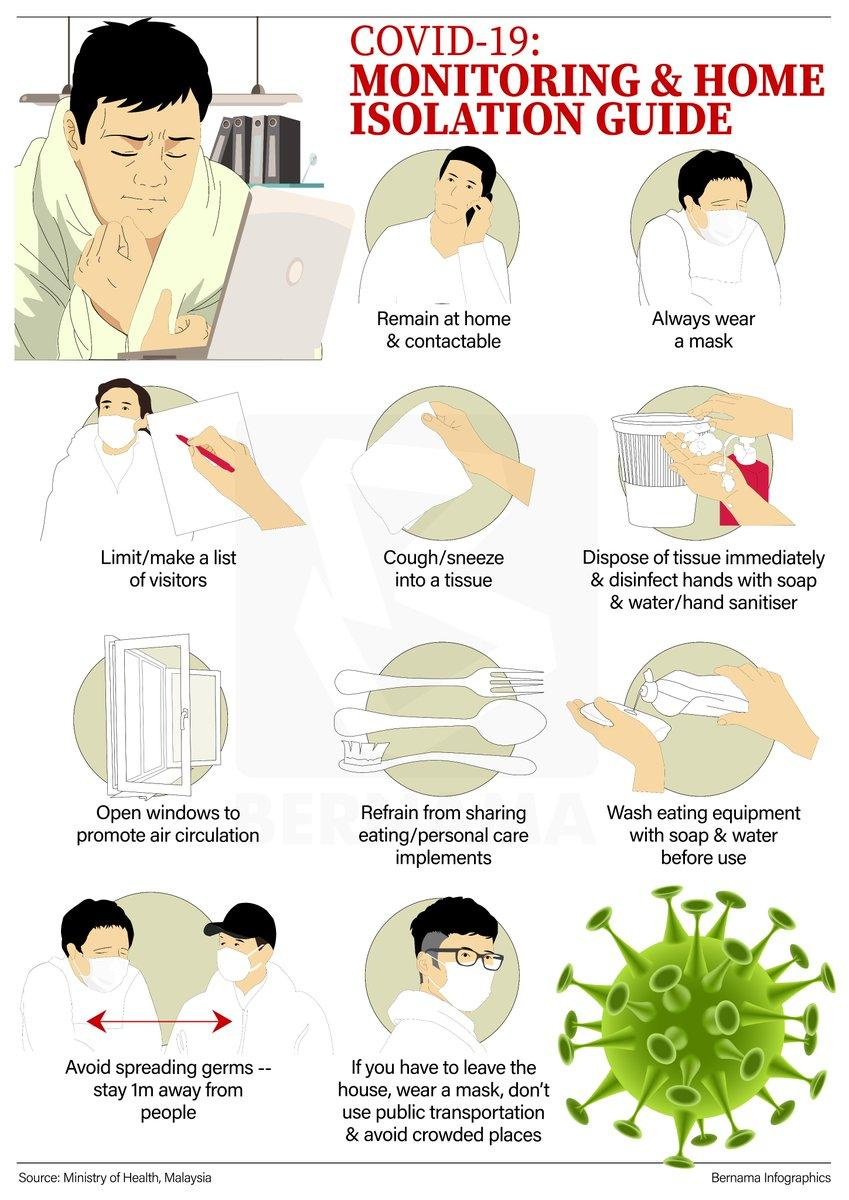Identify some key points in this picture. The infographic depicts approximately 5 people wearing masks. The infographic depicts 7 men in total. The color of the corona virus icon is green. 